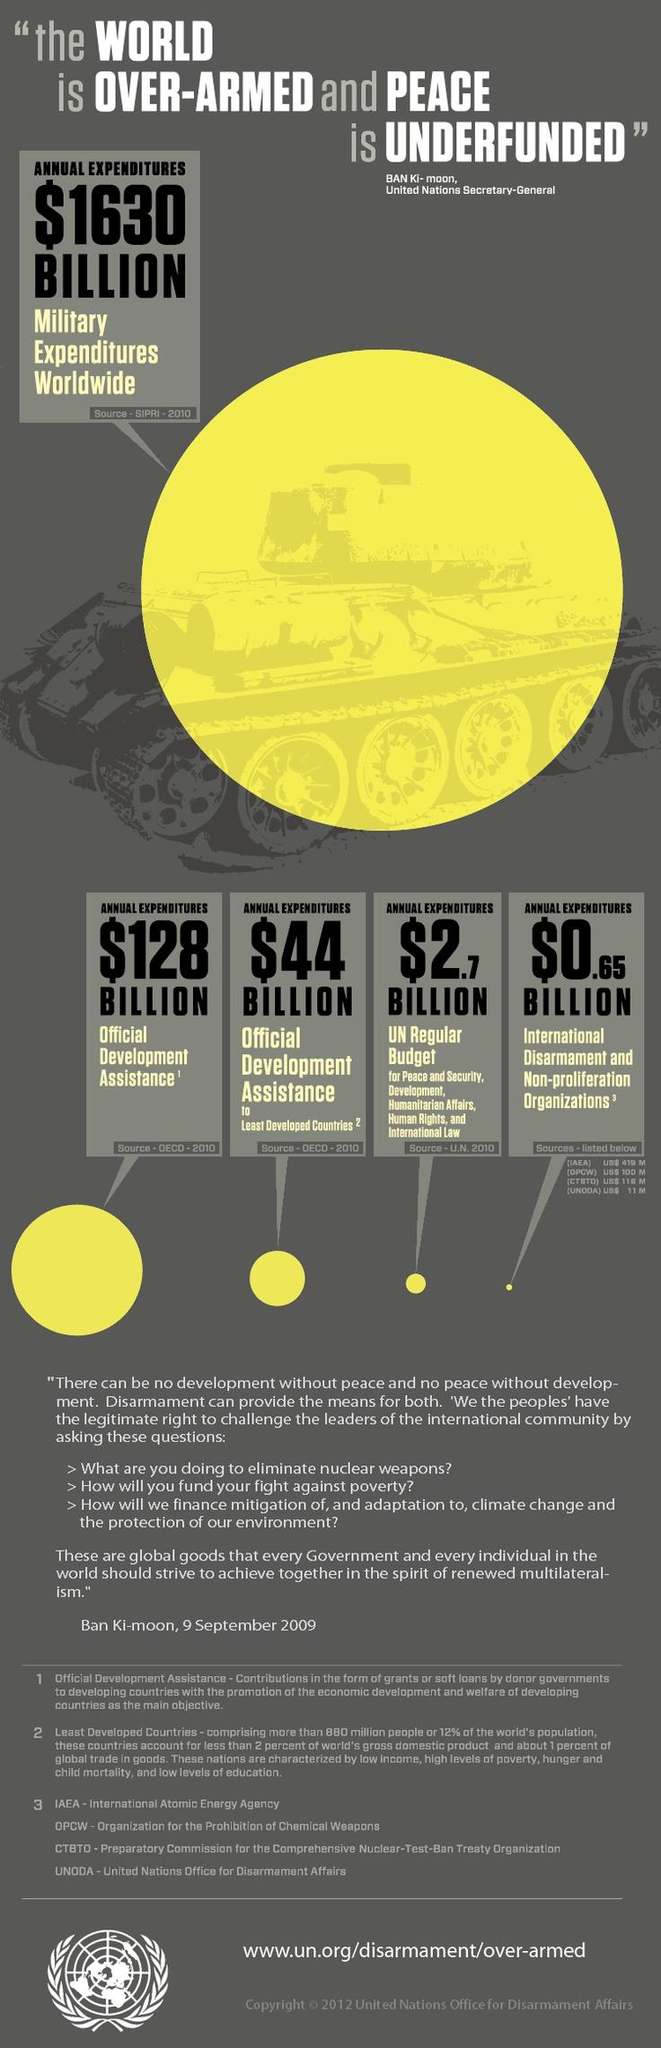Give some essential details in this illustration. The annual expenditure for official development assistance to least developed countries is approximately $44 billion. According to the latest estimates, the annual expenditure for International Disarmament & Non-proliferation Organizations is approximately $0.65 billion. 